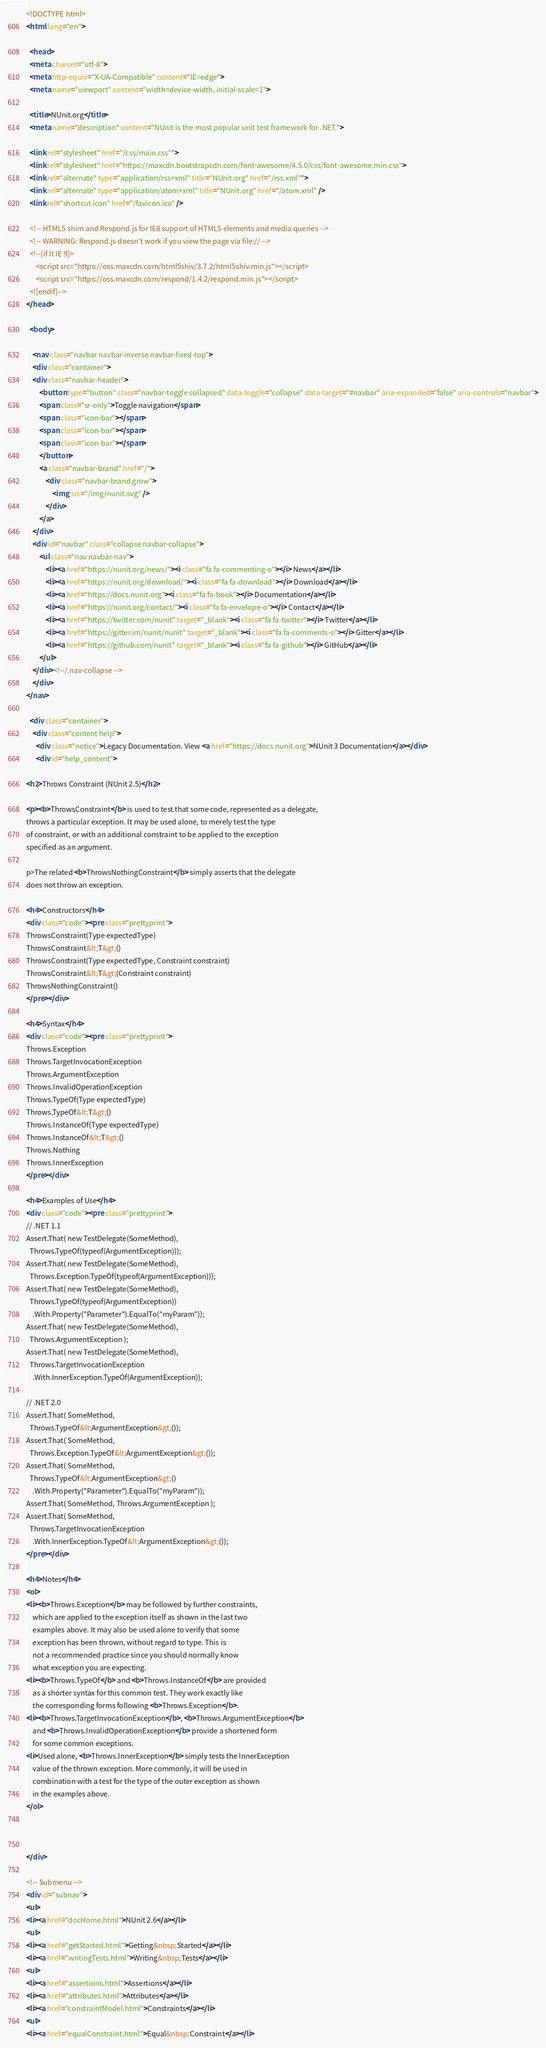<code> <loc_0><loc_0><loc_500><loc_500><_HTML_><!DOCTYPE html>
<html lang="en">

  <head>
  <meta charset="utf-8">
  <meta http-equiv="X-UA-Compatible" content="IE=edge">
  <meta name="viewport" content="width=device-width, initial-scale=1">

  <title>NUnit.org</title>
  <meta name="description" content="NUnit is the most popular unit test framework for .NET.">

  <link rel="stylesheet" href="/css/main.css"">
  <link rel="stylesheet" href="https://maxcdn.bootstrapcdn.com/font-awesome/4.5.0/css/font-awesome.min.css">
  <link rel="alternate" type="application/rss+xml" title="NUnit.org" href="/rss.xml"">
  <link rel="alternate" type="application/atom+xml" title="NUnit.org" href="/atom.xml" />
  <link rel="shortcut icon" href="/favicon.ico" />

  <!-- HTML5 shim and Respond.js for IE8 support of HTML5 elements and media queries -->
  <!-- WARNING: Respond.js doesn't work if you view the page via file:// -->
  <!--[if lt IE 9]>
      <script src="https://oss.maxcdn.com/html5shiv/3.7.2/html5shiv.min.js"></script>
      <script src="https://oss.maxcdn.com/respond/1.4.2/respond.min.js"></script>
  <![endif]-->
</head>

  <body>

    <nav class="navbar navbar-inverse navbar-fixed-top">
    <div class="container">
    <div class="navbar-header">
        <button type="button" class="navbar-toggle collapsed" data-toggle="collapse" data-target="#navbar" aria-expanded="false" aria-controls="navbar">
        <span class="sr-only">Toggle navigation</span>
        <span class="icon-bar"></span>
        <span class="icon-bar"></span>
        <span class="icon-bar"></span>
        </button>
        <a class="navbar-brand" href="/">
            <div class="navbar-brand grow">
                <img src="/img/nunit.svg" />
            </div>
        </a>
    </div>
    <div id="navbar" class="collapse navbar-collapse">
        <ul class="nav navbar-nav">
            <li><a href="https://nunit.org/news/"><i class="fa fa-commenting-o"></i> News</a></li>
            <li><a href="https://nunit.org/download/"><i class="fa fa-download"></i> Download</a></li>
            <li><a href="https://docs.nunit.org"><i class="fa fa-book"></i> Documentation</a></li>
            <li><a href="https://nunit.org/contact/"><i class="fa fa-envelope-o"></i> Contact</a></li>
            <li><a href="https://twitter.com/nunit" target="_blank"><i class="fa fa-twitter"></i> Twitter</a></li>
            <li><a href="https://gitter.im/nunit/nunit" target="_blank"><i class="fa fa-comments-o"></i> Gitter</a></li>
            <li><a href="https://github.com/nunit" target="_blank"><i class="fa fa-github"></i> GitHub</a></li>
        </ul>
    </div><!--/.nav-collapse -->
    </div>
</nav>

  <div class="container">
    <div class="content help">
      <div class="notice">Legacy Documentation. View <a href="https://docs.nunit.org">NUnit 3 Documentation</a></div>
      <div id="help_content">

<h2>Throws Constraint (NUnit 2.5)</h2>

<p><b>ThrowsConstraint</b> is used to test that some code, represented as a delegate,
throws a particular exception. It may be used alone, to merely test the type
of constraint, or with an additional constraint to be applied to the exception
specified as an argument.

p>The related <b>ThrowsNothingConstraint</b> simply asserts that the delegate
does not throw an exception.

<h4>Constructors</h4>
<div class="code"><pre class="prettyprint">
ThrowsConstraint(Type expectedType)
ThrowsConstraint&lt;T&gt;()
ThrowsConstraint(Type expectedType, Constraint constraint)
ThrowsConstraint&lt;T&gt;(Constraint constraint)
ThrowsNothingConstraint()
</pre></div>

<h4>Syntax</h4>
<div class="code"><pre class="prettyprint">
Throws.Exception
Throws.TargetInvocationException
Throws.ArgumentException
Throws.InvalidOperationException
Throws.TypeOf(Type expectedType)
Throws.TypeOf&lt;T&gt;()
Throws.InstanceOf(Type expectedType)
Throws.InstanceOf&lt;T&gt;()
Throws.Nothing
Throws.InnerException
</pre></div>

<h4>Examples of Use</h4>
<div class="code"><pre class="prettyprint">
// .NET 1.1
Assert.That( new TestDelegate(SomeMethod),
  Throws.TypeOf(typeof(ArgumentException)));
Assert.That( new TestDelegate(SomeMethod),
  Throws.Exception.TypeOf(typeof(ArgumentException)));
Assert.That( new TestDelegate(SomeMethod),
  Throws.TypeOf(typeof(ArgumentException))
    .With.Property("Parameter").EqualTo("myParam"));
Assert.That( new TestDelegate(SomeMethod),
  Throws.ArgumentException );
Assert.That( new TestDelegate(SomeMethod),
  Throws.TargetInvocationException
    .With.InnerException.TypeOf(ArgumentException));

// .NET 2.0
Assert.That( SomeMethod,
  Throws.TypeOf&lt;ArgumentException&gt;());
Assert.That( SomeMethod,
  Throws.Exception.TypeOf&lt;ArgumentException&gt;());
Assert.That( SomeMethod,
  Throws.TypeOf&lt;ArgumentException&gt;()
    .With.Property("Parameter").EqualTo("myParam"));
Assert.That( SomeMethod, Throws.ArgumentException );
Assert.That( SomeMethod,
  Throws.TargetInvocationException
    .With.InnerException.TypeOf&lt;ArgumentException&gt;());
</pre></div>

<h4>Notes</h4>
<ol>
<li><b>Throws.Exception</b> may be followed by further constraints,
    which are applied to the exception itself as shown in the last two
	examples above. It may also be used alone to verify that some
	exception has been thrown, without regard to type. This is
	not a recommended practice since you should normally know
	what exception you are expecting.
<li><b>Throws.TypeOf</b> and <b>Throws.InstanceOf</b> are provided
    as a shorter syntax for this common test. They work exactly like
	the corresponding forms following <b>Throws.Exception</b>.
<li><b>Throws.TargetInvocationException</b>, <b>Throws.ArgumentException</b>
    and <b>Throws.InvalidOperationException</b> provide a shortened form
	for some common exceptions.
<li>Used alone, <b>Throws.InnerException</b> simply tests the InnerException
    value of the thrown exception. More commonly, it will be used in
	combination with a test for the type of the outer exception as shown
	in the examples above.
</ol>



</div>

<!-- Submenu -->
<div id="subnav">
<ul>
<li><a href="docHome.html">NUnit 2.6</a></li>
<ul>
<li><a href="getStarted.html">Getting&nbsp;Started</a></li>
<li><a href="writingTests.html">Writing&nbsp;Tests</a></li>
<ul>
<li><a href="assertions.html">Assertions</a></li>
<li><a href="attributes.html">Attributes</a></li>
<li><a href="constraintModel.html">Constraints</a></li>
<ul>
<li><a href="equalConstraint.html">Equal&nbsp;Constraint</a></li></code> 